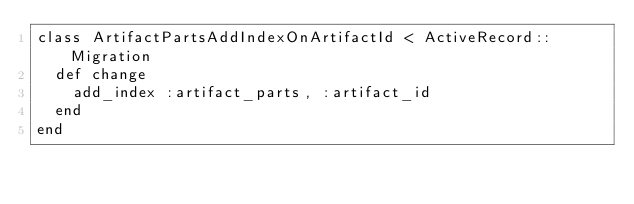<code> <loc_0><loc_0><loc_500><loc_500><_Ruby_>class ArtifactPartsAddIndexOnArtifactId < ActiveRecord::Migration
  def change
    add_index :artifact_parts, :artifact_id
  end
end

</code> 